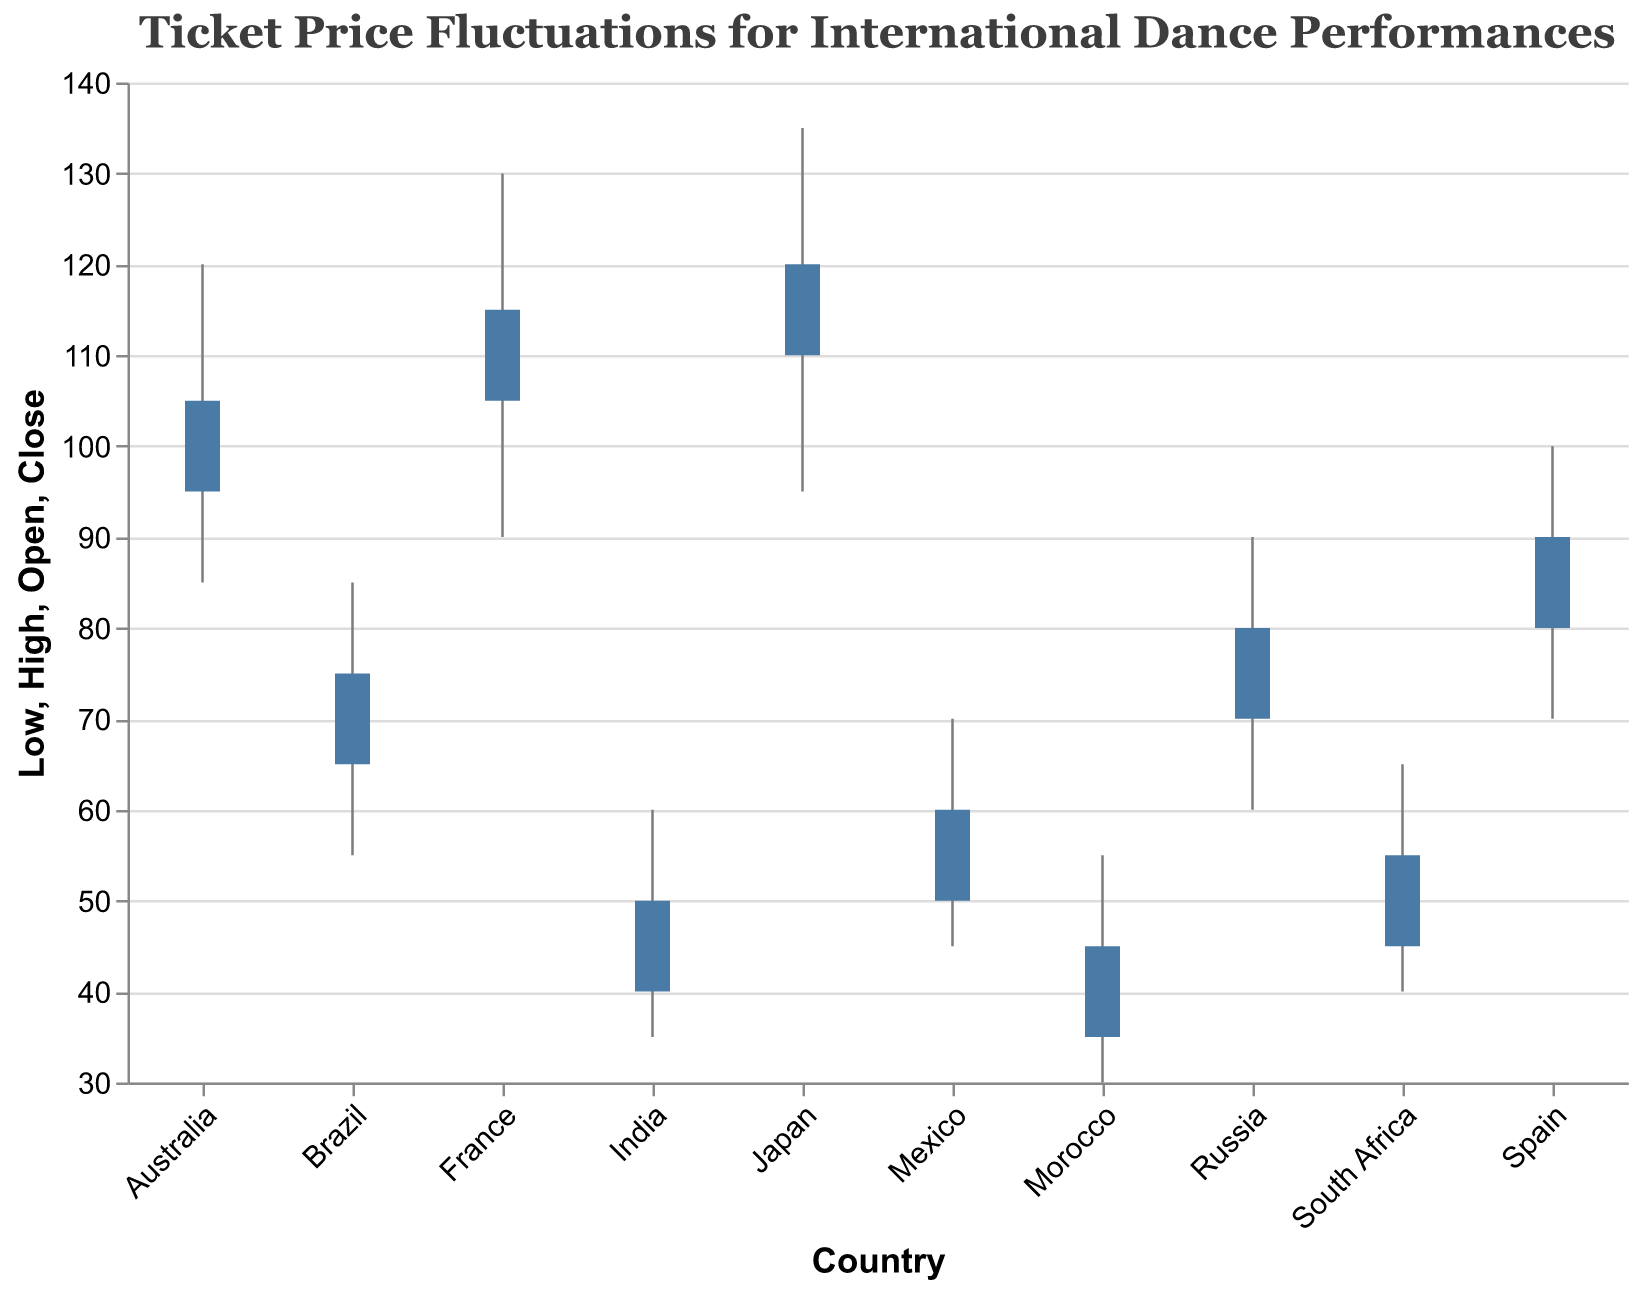What is the title of the chart? The title of the chart is displayed at the top and indicates the focus of the data being presented. The visual title reads "Ticket Price Fluctuations for International Dance Performances".
Answer: Ticket Price Fluctuations for International Dance Performances How many countries are included in the chart? By counting the unique country names along the x-axis, we can determine the number of separate countries represented in the chart.
Answer: 10 What was the highest ticket price recorded for Japan? The vertical extent of the rule mark (line) for Japan represents the range between the lowest and highest ticket prices. The endpoint of the upper part of the line corresponds to the highest price.
Answer: 135 Which country had the lowest opening ticket price? By examining the bar marks that extend from the opening to the closing prices for each country, we identify the lowest opening value to determine the country.
Answer: Morocco For Brazil, by how much did the closing ticket price differ from the opening ticket price? To find the difference, subtract the opening price from the closing price for Brazil. The opening price is 65 and the closing price is 75, so 75 - 65 = 10.
Answer: 10 Which country had the smallest range in ticket prices? The range in ticket prices for each country is determined by subtracting the lowest ticket price from the highest. We need to compute this for each country and find the smallest range.
Answer: Morocco Compare the closing ticket prices between South Africa and Mexico. Which country had a higher closing price? By looking at the "Close" end of the bar mark for both South Africa and Mexico, we compare the values. South Africa's close price is 55 and Mexico's is 60.
Answer: Mexico What was the ticket price range (high minus low) for France? To determine the range for France, subtract the lowest ticket price from the highest ticket price. The high is 130 and the low is 90, so 130 - 90 = 40.
Answer: 40 Did any country have the same opening and closing ticket price? Each bar mark representing the range from opening to closing prices must be checked. If any bar has no height (i.e., the top and bottom are the same), that country had the same opening and closing prices.
Answer: No 